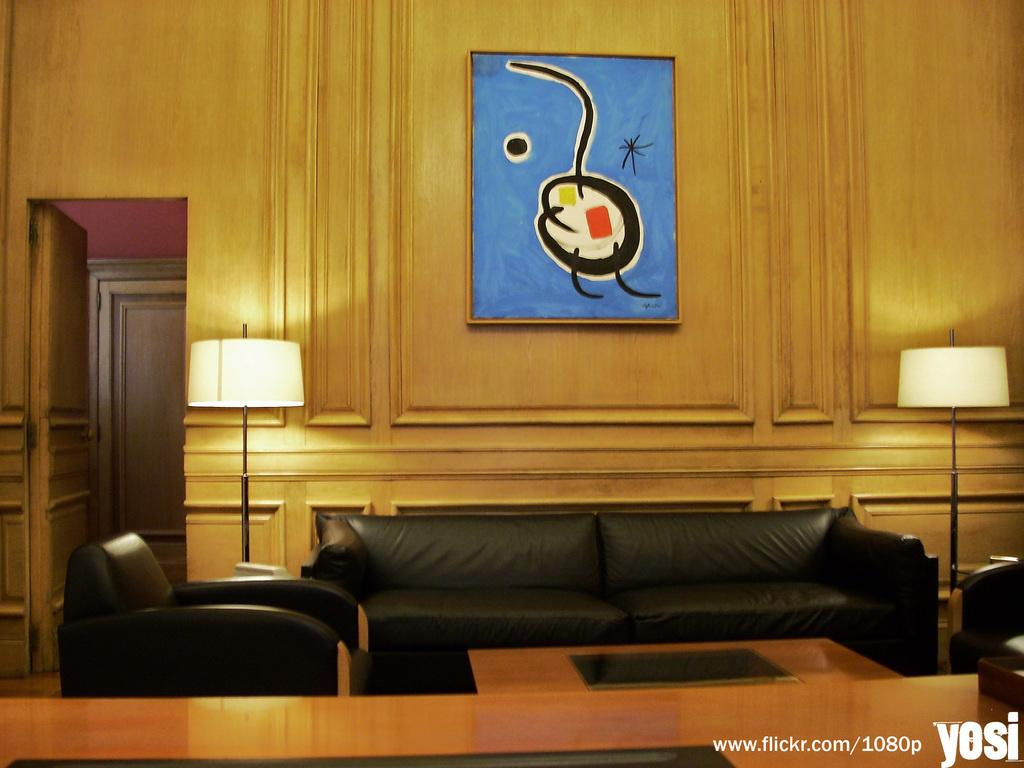What type of space is depicted in the image? There is a room in the image. What furniture is present in the room? There is a sofa and a table in the room. What can be used for illumination in the room? There are lights in the room. How can one enter or exit the room? There is a door in the room. What decorative elements are on the walls in the room? There are frames on the wall in the room. What type of grass can be seen growing on the sofa in the image? There is no grass present in the image, let alone growing on the sofa. 